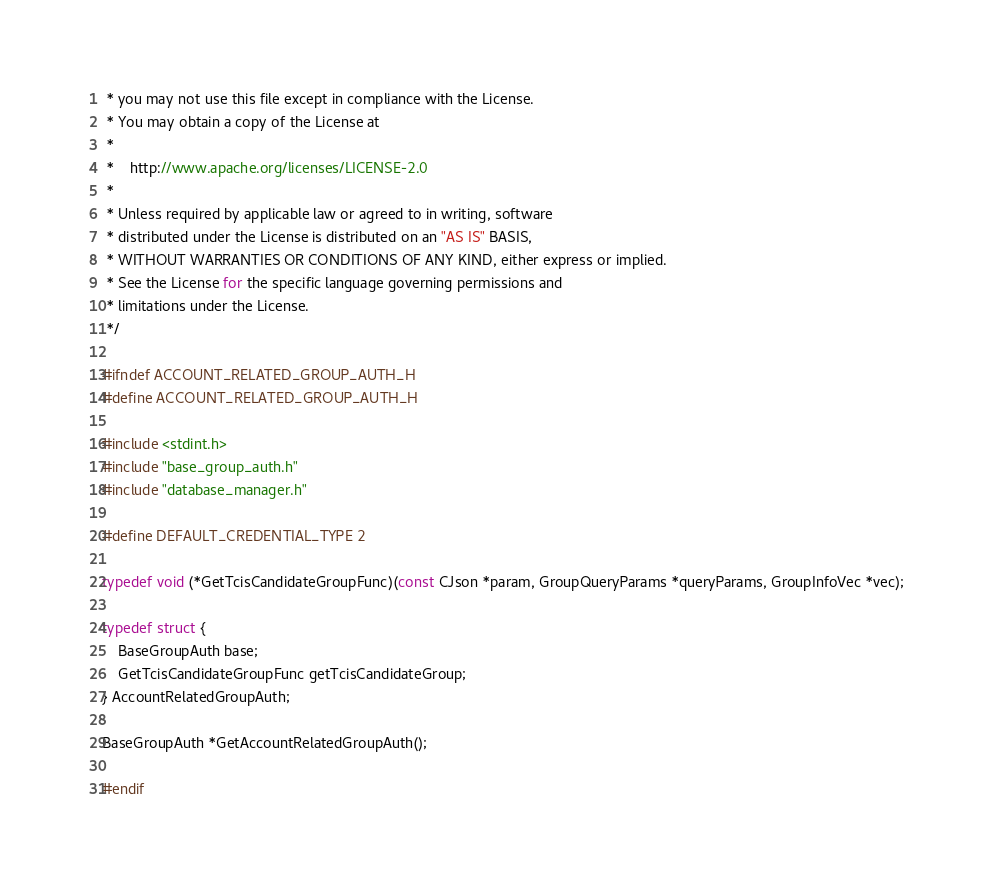Convert code to text. <code><loc_0><loc_0><loc_500><loc_500><_C_> * you may not use this file except in compliance with the License.
 * You may obtain a copy of the License at
 *
 *    http://www.apache.org/licenses/LICENSE-2.0
 *
 * Unless required by applicable law or agreed to in writing, software
 * distributed under the License is distributed on an "AS IS" BASIS,
 * WITHOUT WARRANTIES OR CONDITIONS OF ANY KIND, either express or implied.
 * See the License for the specific language governing permissions and
 * limitations under the License.
 */

#ifndef ACCOUNT_RELATED_GROUP_AUTH_H
#define ACCOUNT_RELATED_GROUP_AUTH_H

#include <stdint.h>
#include "base_group_auth.h"
#include "database_manager.h"

#define DEFAULT_CREDENTIAL_TYPE 2

typedef void (*GetTcisCandidateGroupFunc)(const CJson *param, GroupQueryParams *queryParams, GroupInfoVec *vec);

typedef struct {
    BaseGroupAuth base;
    GetTcisCandidateGroupFunc getTcisCandidateGroup;
} AccountRelatedGroupAuth;

BaseGroupAuth *GetAccountRelatedGroupAuth();

#endif
</code> 